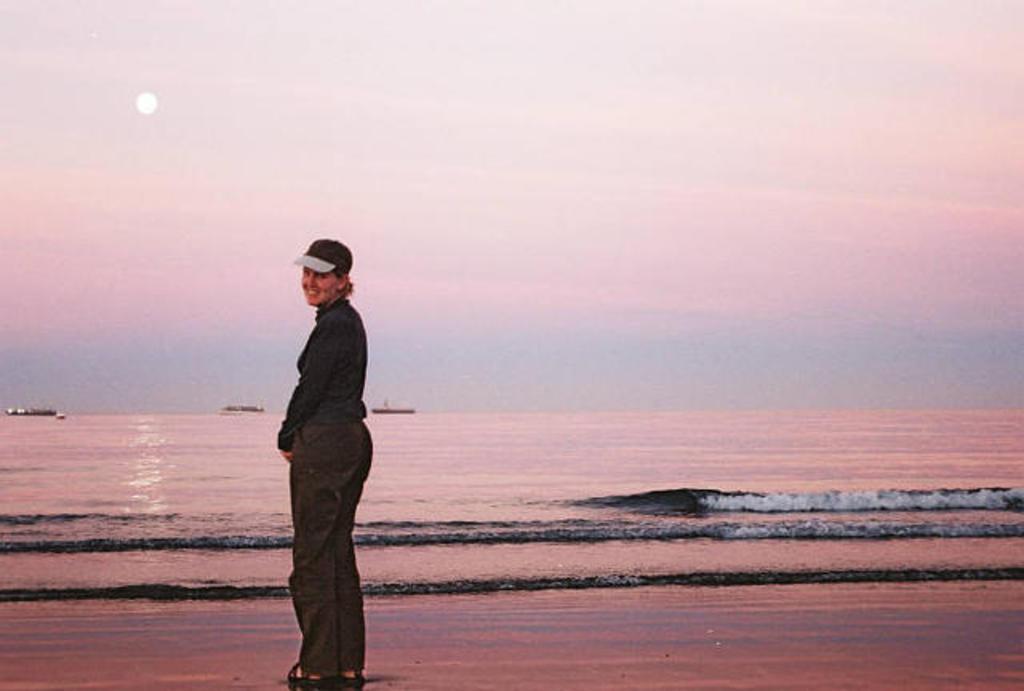Please provide a concise description of this image. In the image there is a woman standing and smiling, behind her there is a sea and there are three boats sailing on the sea. 